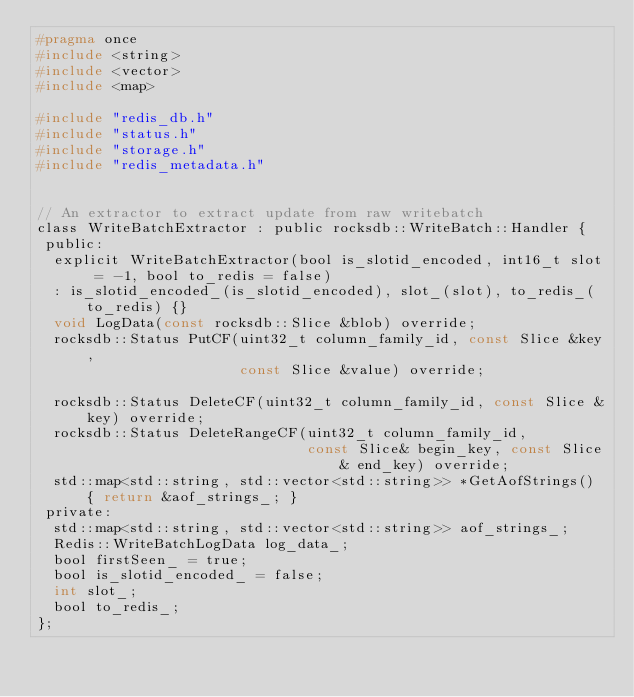Convert code to text. <code><loc_0><loc_0><loc_500><loc_500><_C_>#pragma once
#include <string>
#include <vector>
#include <map>

#include "redis_db.h"
#include "status.h"
#include "storage.h"
#include "redis_metadata.h"


// An extractor to extract update from raw writebatch
class WriteBatchExtractor : public rocksdb::WriteBatch::Handler {
 public:
  explicit WriteBatchExtractor(bool is_slotid_encoded, int16_t slot = -1, bool to_redis = false)
  : is_slotid_encoded_(is_slotid_encoded), slot_(slot), to_redis_(to_redis) {}
  void LogData(const rocksdb::Slice &blob) override;
  rocksdb::Status PutCF(uint32_t column_family_id, const Slice &key,
                        const Slice &value) override;

  rocksdb::Status DeleteCF(uint32_t column_family_id, const Slice &key) override;
  rocksdb::Status DeleteRangeCF(uint32_t column_family_id,
                                const Slice& begin_key, const Slice& end_key) override;
  std::map<std::string, std::vector<std::string>> *GetAofStrings() { return &aof_strings_; }
 private:
  std::map<std::string, std::vector<std::string>> aof_strings_;
  Redis::WriteBatchLogData log_data_;
  bool firstSeen_ = true;
  bool is_slotid_encoded_ = false;
  int slot_;
  bool to_redis_;
};
</code> 